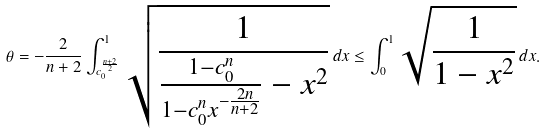<formula> <loc_0><loc_0><loc_500><loc_500>\theta = - \frac { 2 } { n + 2 } \int _ { c _ { 0 } ^ { \frac { n + 2 } { 2 } } } ^ { 1 } \sqrt { \frac { 1 } { \frac { 1 - c _ { 0 } ^ { n } } { 1 - c _ { 0 } ^ { n } x ^ { - \frac { 2 n } { n + 2 } } } - x ^ { 2 } } } \, d x \leq \int _ { 0 } ^ { 1 } \sqrt { \frac { 1 } { 1 - x ^ { 2 } } } \, d x .</formula> 